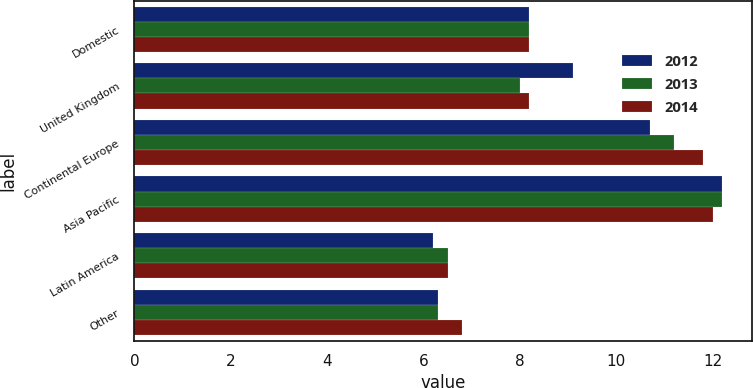Convert chart to OTSL. <chart><loc_0><loc_0><loc_500><loc_500><stacked_bar_chart><ecel><fcel>Domestic<fcel>United Kingdom<fcel>Continental Europe<fcel>Asia Pacific<fcel>Latin America<fcel>Other<nl><fcel>2012<fcel>8.2<fcel>9.1<fcel>10.7<fcel>12.2<fcel>6.2<fcel>6.3<nl><fcel>2013<fcel>8.2<fcel>8<fcel>11.2<fcel>12.2<fcel>6.5<fcel>6.3<nl><fcel>2014<fcel>8.2<fcel>8.2<fcel>11.8<fcel>12<fcel>6.5<fcel>6.8<nl></chart> 